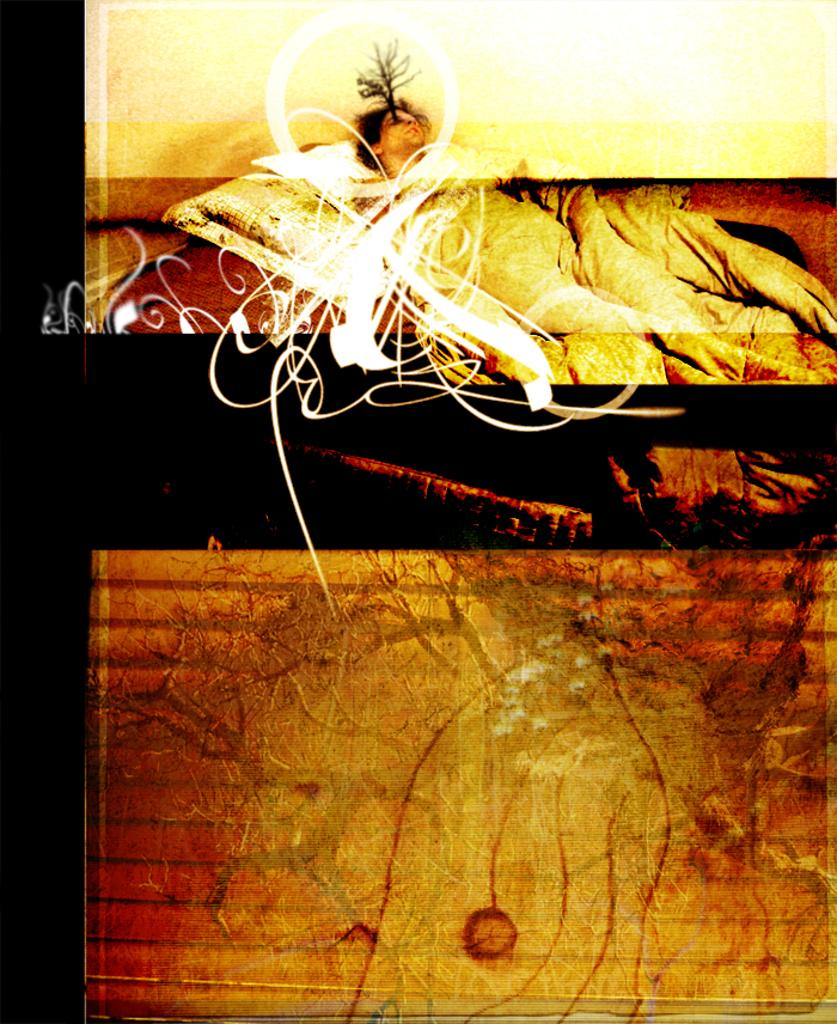What is located at the bottom of the image? There is a wall at the bottom of the image. What can be seen in the image besides the wall? There is a person lying on a bed in the image. Where is the person located in relation to the wall? The person is visible at the top of the image. Is there a river flowing through the alley in the image? There is no alley or river present in the image. How does the rainstorm affect the person lying on the bed in the image? There is no rainstorm present in the image, so it does not affect the person lying on the bed. 